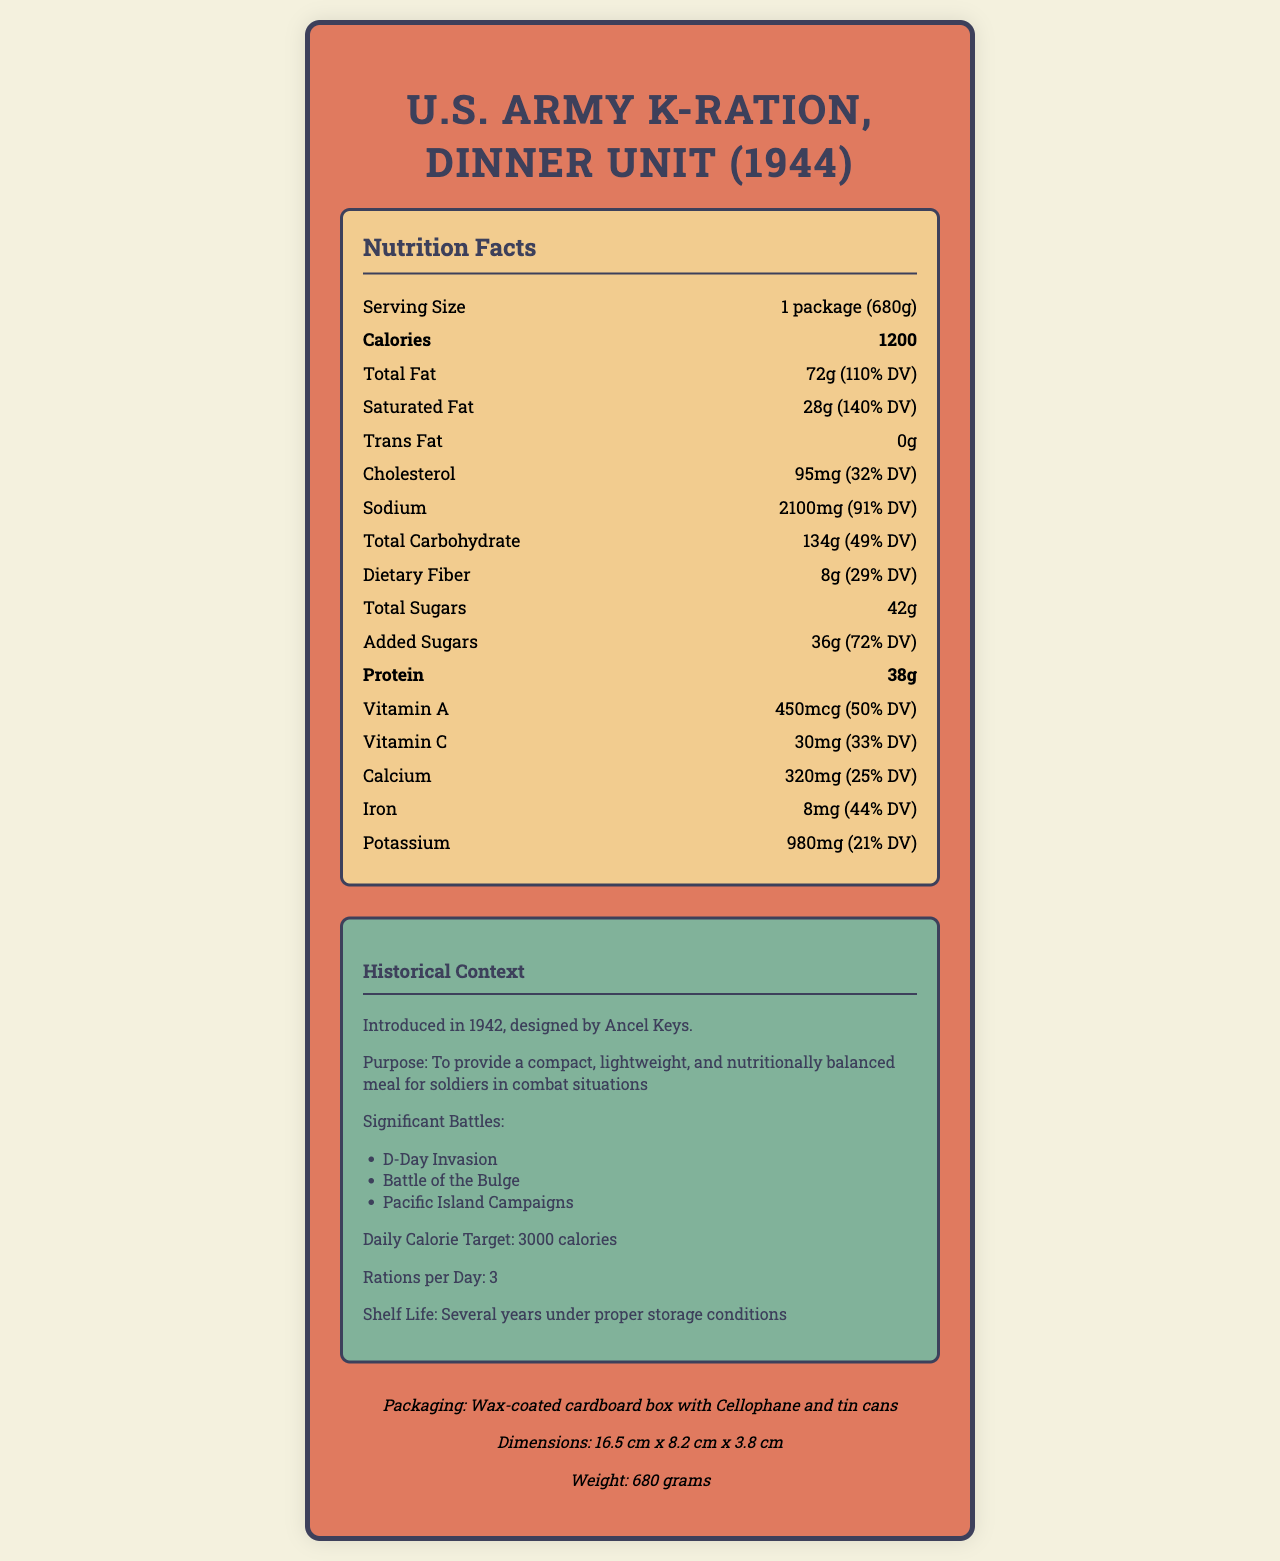what is the serving size for the U.S. Army K-Ration, Dinner Unit (1944)? The serving size is explicitly mentioned as "1 package (680g)" under the Nutrition Facts section.
Answer: 1 package (680g) how many calories are in one serving of this K-Ration? The document lists the calories per serving as 1200.
Answer: 1200 how much protein is in one serving? Under the Nutrition Facts section, the amount of protein per serving is shown to be 38g.
Answer: 38g what is the daily value percentage for Vitamin A? The Nutrition Facts section indicates that Vitamin A constitutes 50% of the daily value.
Answer: 50% how much sodium does this ration pack contain? The amount of sodium is listed in the Nutrition Facts section as 2100mg, which represents 91% of the daily value.
Answer: 2100mg what was the primary design purpose of the K-Ration? The purpose is outlined in the Historical Context section, stating it was designed to be a compact, lightweight, and nutritionally balanced meal.
Answer: To provide a compact, lightweight, and nutritionally balanced meal for soldiers in combat situations in which year was the K-Ration introduced? According to the Historical Context section, the K-Ration was introduced in 1942.
Answer: 1942 how many grams of total carbohydrates are in the ration pack? A. 100g B. 134g C. 150g The Nutrition Facts section shows that the total carbohydrates amount to 134g per serving.
Answer: B. 134g who designed the K-Ration? A. Ancel Keys B. Jonas Salk C. Dwight D. Eisenhower The document mentions that Ancel Keys designed the K-Ration in the Historical Context section.
Answer: A. Ancel Keys is there any trans fat in the U.S. Army K-Ration, Dinner Unit (1944)? The Nutrition Facts section specifically lists the amount of trans fat as 0g.
Answer: No describe the different components included in this ration. The Ingredients section lists all these components as part of the ration pack.
Answer: The ration pack includes canned meat (either pork or beef), biscuits, cheese, a fruit bar, a chocolate bar, instant coffee, sugar, salt, chewing gum, cigarettes, and toilet paper. what is the significant battle not mentioned in the document? The document lists D-Day Invasion, Battle of the Bulge, and Pacific Island Campaigns as significant battles. Any battle not listed is not provided in the document and thus cannot be determined.
Answer: I don't know what is the outer packaging of the K-Ration composed of? The Packaging Details section specifies the outer wrapper as a wax-coated cardboard box.
Answer: Wax-coated cardboard box what is the ratio of total sugars to added sugars in the K-Ration? The Nutrition Facts section provides these values, showing a total sugar content of 42g with added sugars making up 36g of that amount.
Answer: Total Sugars: 42g, Added Sugars: 36g did the K-Ration include vitamins like Vitamin C and A, and to what extent? The document lists the amounts and daily values for both Vitamin C (30mg, 33% DV) and Vitamin A (450mcg, 50% DV).
Answer: Yes, 33% DV of Vitamin C, and 50% DV of Vitamin A is the total fat daily value above 100%? The total fat content is 72g, which accounts for 110% of the daily value, as per the Nutrition Facts section.
Answer: Yes 